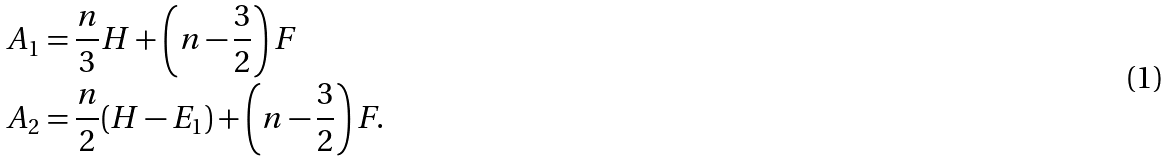Convert formula to latex. <formula><loc_0><loc_0><loc_500><loc_500>A _ { 1 } & = \frac { n } { 3 } H + \left ( n - \frac { 3 } { 2 } \right ) F \\ A _ { 2 } & = \frac { n } { 2 } ( H - E _ { 1 } ) + \left ( n - \frac { 3 } { 2 } \right ) F .</formula> 